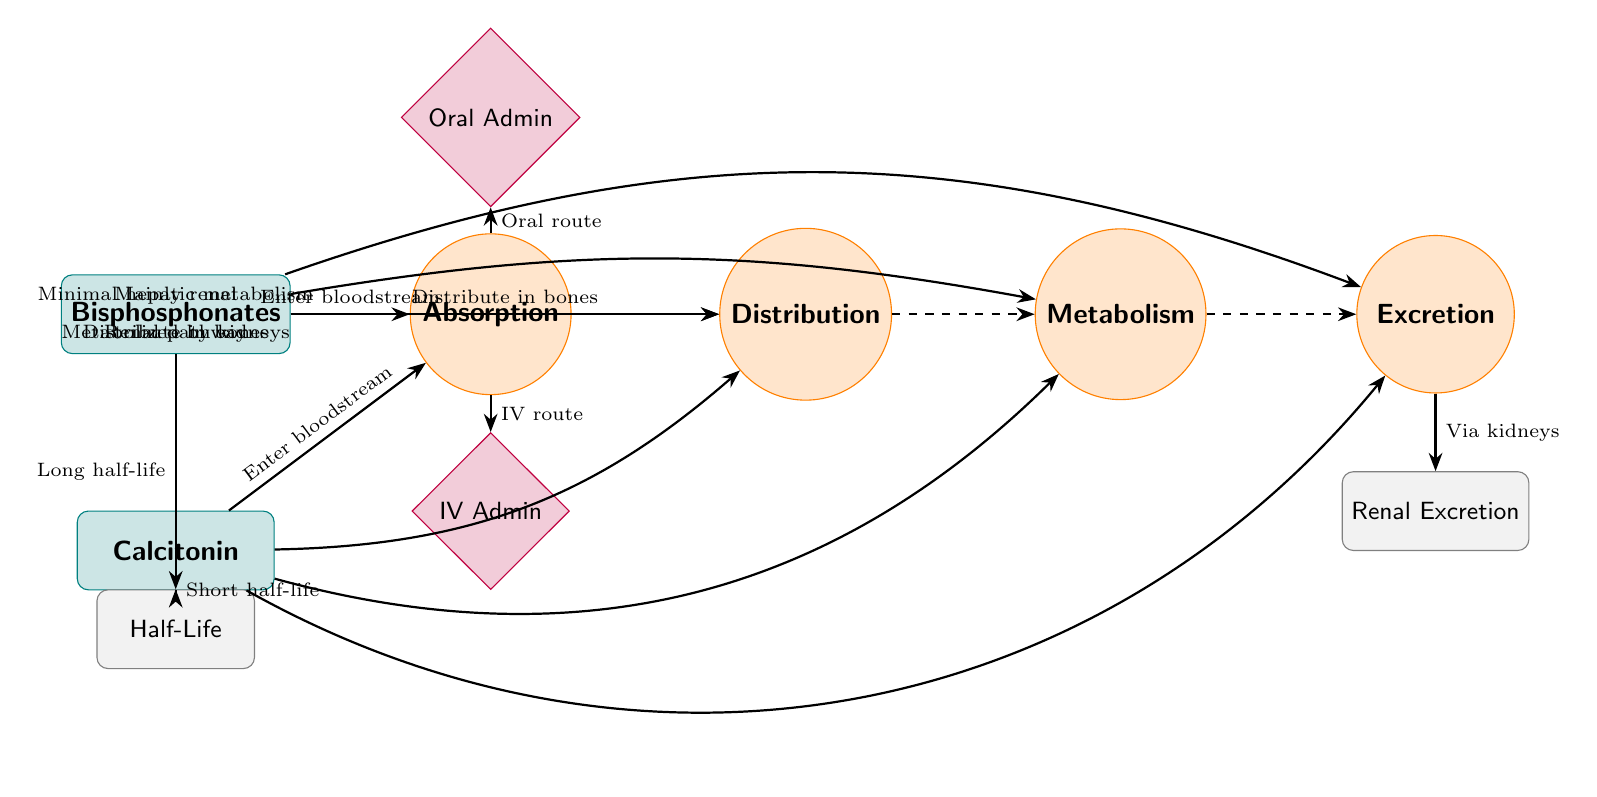What medications are used for Paget's disease? The diagram shows two medications: Bisphosphonates and Calcitonin. They are identified as the starting nodes in the diagram's flow.
Answer: Bisphosphonates, Calcitonin What is the administration route for Bisphosphonates? The diagram indicates that Bisphosphonates can be administered orally or intravenously, clearly showing these options connected to the absorption stage.
Answer: Oral Admin, IV Admin Which medication has a long half-life? The diagram asserts that Bisphosphonates have a long half-life, while the information about the half-lives of both medications is specified next to each medication.
Answer: Long half-life What type of metabolism does Bisphosphonates undergo? In the diagram, it indicates "Minimal hepatic metabolism" for Bisphosphonates, as labeled on the connection to the metabolism node.
Answer: Minimal hepatic metabolism How do you describe the excretion pathway for Calcitonin? The diagram shows that Calcitonin is excreted mainly through the renal pathway, connecting it to the excretion node, and further specified as renal excretion.
Answer: Renal pathway What connects the absorption process to distribution? The diagram illustrates a dashed arrow representing the connection between absorption and distribution, indicating there is a flow from one process to the next.
Answer: Dashed arrow What is the main process for excretion of medications for Paget's disease? The diagram indicates that the main process of excretion for both medications involves the kidneys as shown through the flow leading to renal excretion.
Answer: Via kidneys Which medication distributes in bones? The diagram indicates that both Bisphosphonates and Calcitonin distribute in bones, as both are linked to the distribution node indicating a common characteristic.
Answer: Distribute in bones What route of administration is not used for Calcitonin? By checking the connections in the diagram, Calcitonin does not have an arrow leading to the oral administration node, indicating it is not administrable via that route.
Answer: Oral Admin 